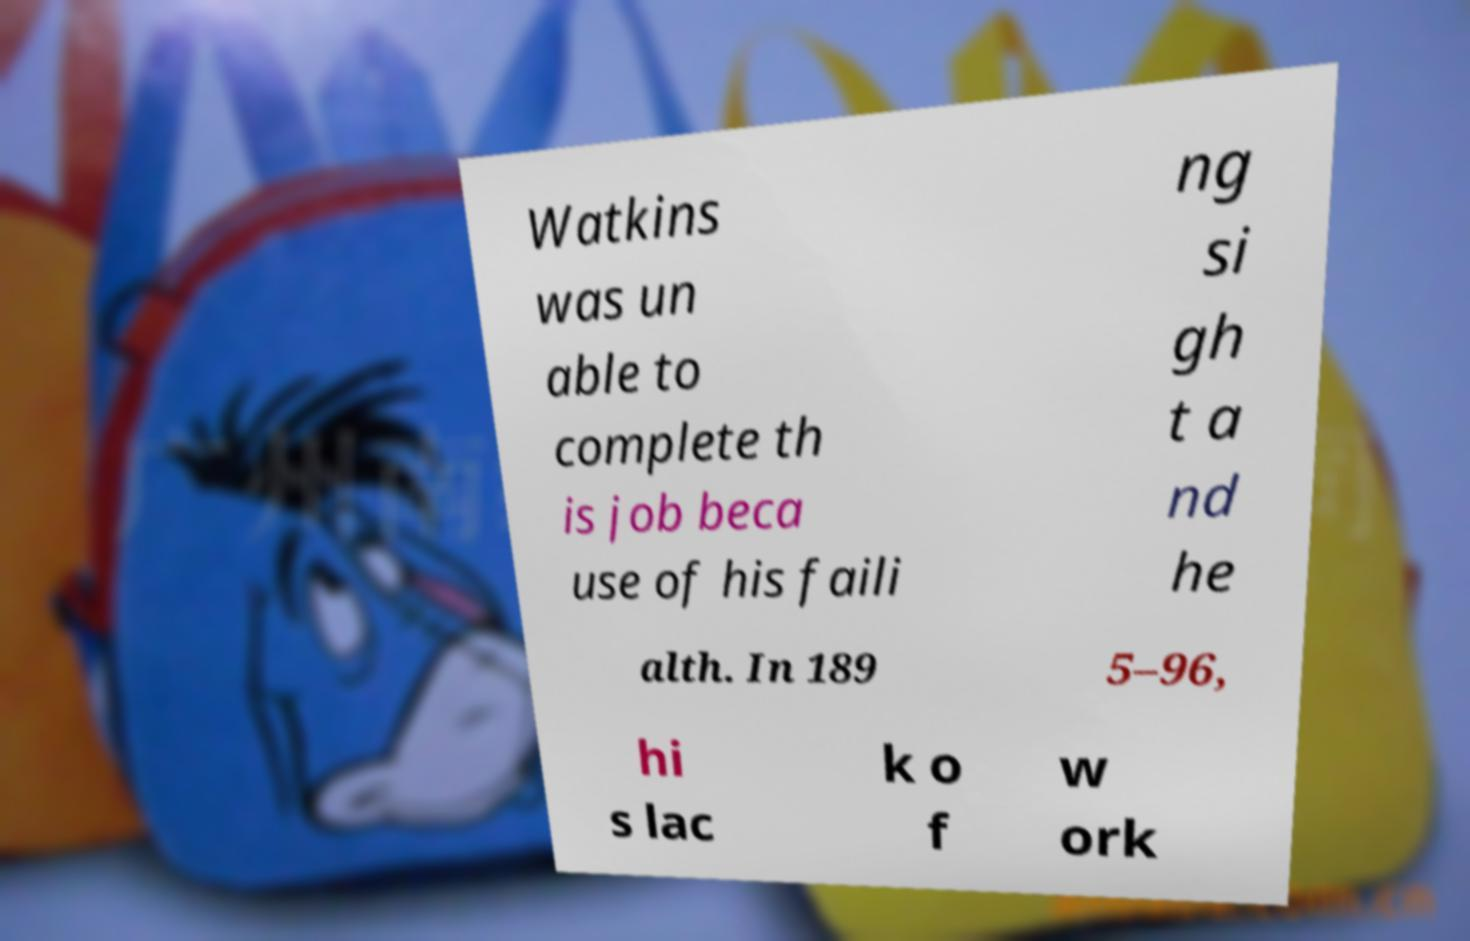There's text embedded in this image that I need extracted. Can you transcribe it verbatim? Watkins was un able to complete th is job beca use of his faili ng si gh t a nd he alth. In 189 5–96, hi s lac k o f w ork 